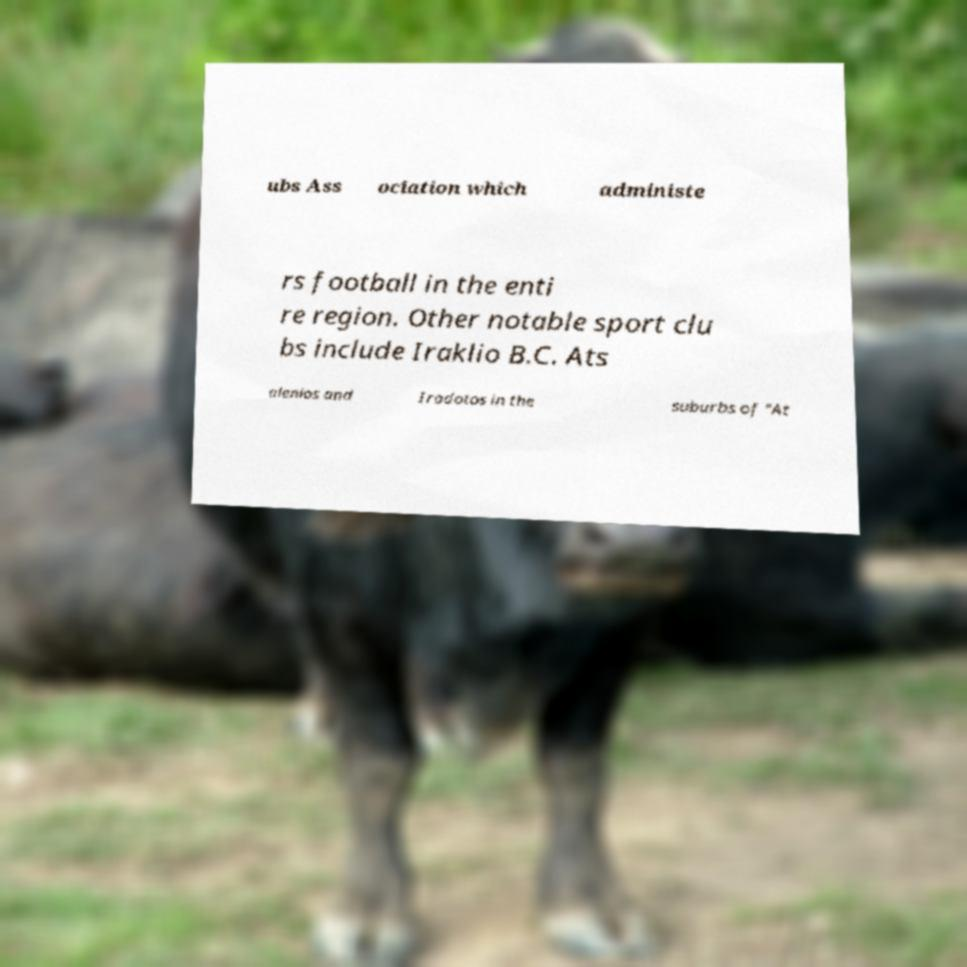What messages or text are displayed in this image? I need them in a readable, typed format. ubs Ass ociation which administe rs football in the enti re region. Other notable sport clu bs include Iraklio B.C. Ats alenios and Irodotos in the suburbs of "At 